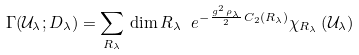Convert formula to latex. <formula><loc_0><loc_0><loc_500><loc_500>\Gamma ( \mathcal { U } _ { \lambda } ; D _ { \lambda } ) = \sum _ { R _ { \lambda } } \, \dim R _ { \lambda } \ e ^ { - \frac { g ^ { 2 } \, \rho _ { \lambda } } { 2 } \, C _ { 2 } ( R _ { \lambda } ) } \chi _ { R _ { \lambda } } \left ( \mathcal { U } _ { \lambda } \right )</formula> 